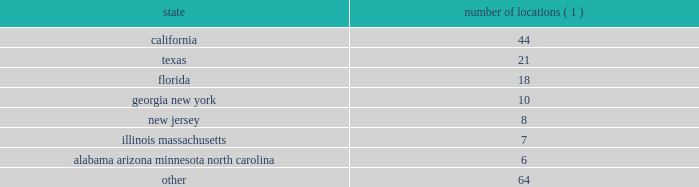2022 the ability to identify suitable acquisition candidates and the ability to finance such acquisitions , which depends upon the availability of adequate cash reserves from operations or of acceptable financing terms and the variability of our stock price ; 2022 our ability to integrate any acquired business 2019 operations , services , clients , and personnel ; 2022 the effect of our substantial leverage , which may limit the funds available to make acquisitions and invest in our business ; 2022 changes in , or the failure to comply with , government regulations , including privacy regulations ; and 2022 other risks detailed elsewhere in this risk factors section and in our other filings with the securities and exchange commission .
We are not under any obligation ( and expressly disclaim any such obligation ) to update or alter our forward- looking statements , whether as a result of new information , future events or otherwise .
You should carefully consider the possibility that actual results may differ materially from our forward-looking statements .
Item 1b .
Unresolved staff comments .
Item 2 .
Properties .
Our corporate headquarters are located in jacksonville , florida , in an owned facility .
Fnf occupies and pays us rent for approximately 86000 square feet in this facility .
We lease office space as follows : number of locations ( 1 ) .
( 1 ) represents the number of locations in each state listed .
We also lease approximately 72 locations outside the united states .
We believe our properties are adequate for our business as presently conducted .
Item 3 .
Legal proceedings .
In the ordinary course of business , the company is involved in various pending and threatened litigation matters related to operations , some of which include claims for punitive or exemplary damages .
The company believes that no actions , other than the matters listed below , depart from customary litigation incidental to its business .
As background to the disclosure below , please note the following : 2022 these matters raise difficult and complicated factual and legal issues and are subject to many uncertainties and complexities .
2022 the company reviews these matters on an on-going basis and follows the provisions of statement of financial accounting standards no .
5 , accounting for contingencies ( 201csfas 5 201d ) , when making accrual and disclosure decisions .
When assessing reasonably possible and probable outcomes , the company bases decisions on the assessment of the ultimate outcome following all appeals. .
What is the total number of locations leased by fis? 
Computations: (72 + 64)
Answer: 136.0. 